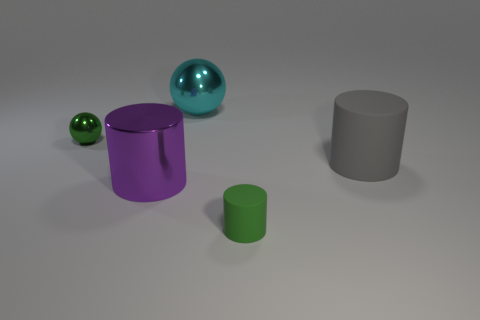What could be the possible sizes of these objects relative to each other? Relative to each other, the teal sphere is the largest object, and the green cylinder is the smallest. The purple cylinder is slightly larger than the green one but smaller than the gray cylinder and the teal sphere. The gray cylinder is larger than both green and purple cylinders but smaller than the teal sphere. If you had to guess, what material might these objects be made of? Based on their appearances, one might speculate that the sphere and cylinders are made of plastic given their smooth surfaces. The reflective nature of the teal sphere suggests it could be a polished or gloss-coated material, while the matte surfaces of the other objects suggest they could be composed of a non-reflective plastic or a similar synthetic material. 